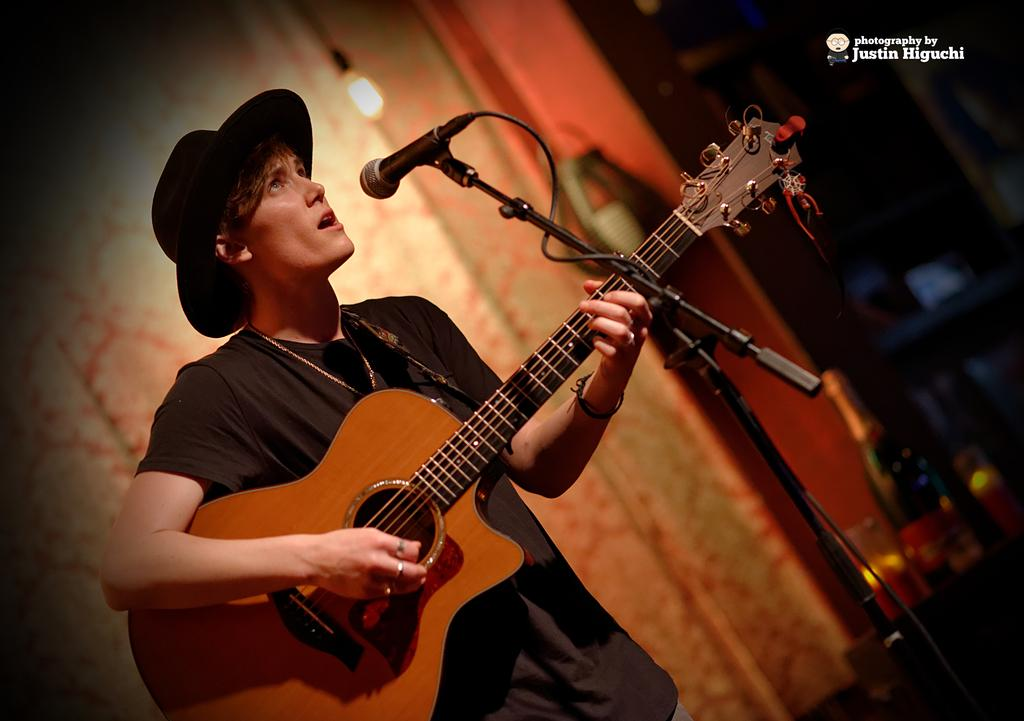What is the man in the image doing? The man is playing a guitar and singing. What object is in front of the man? There is a microphone in front of the man. Can you describe the lighting in the image? There is a light visible in the image. Is there a basketball court visible in the image? No, there is no basketball court present in the image. Can you see a lake in the background of the image? No, there is no lake visible in the image. 